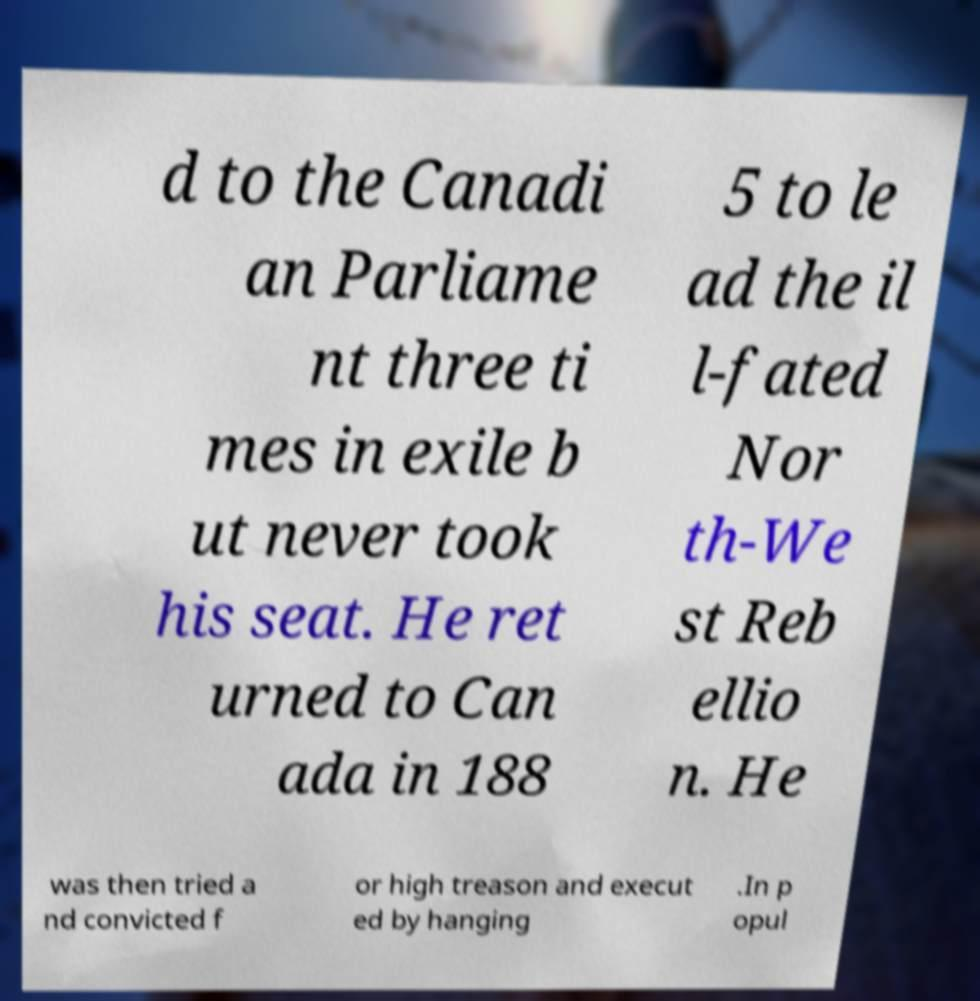Could you assist in decoding the text presented in this image and type it out clearly? d to the Canadi an Parliame nt three ti mes in exile b ut never took his seat. He ret urned to Can ada in 188 5 to le ad the il l-fated Nor th-We st Reb ellio n. He was then tried a nd convicted f or high treason and execut ed by hanging .In p opul 